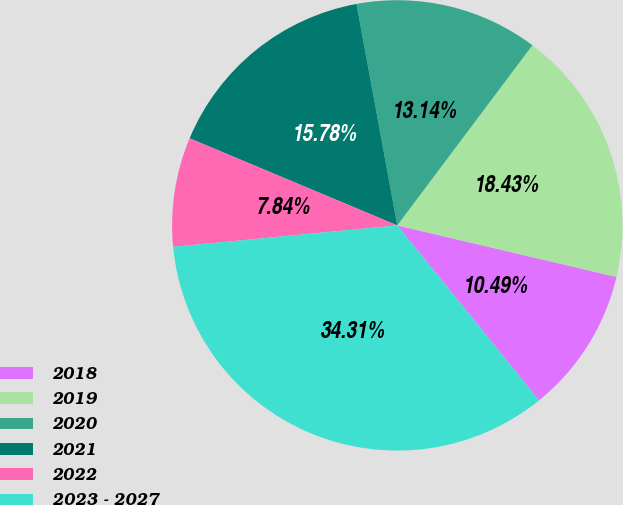Convert chart to OTSL. <chart><loc_0><loc_0><loc_500><loc_500><pie_chart><fcel>2018<fcel>2019<fcel>2020<fcel>2021<fcel>2022<fcel>2023 - 2027<nl><fcel>10.49%<fcel>18.43%<fcel>13.14%<fcel>15.78%<fcel>7.84%<fcel>34.31%<nl></chart> 